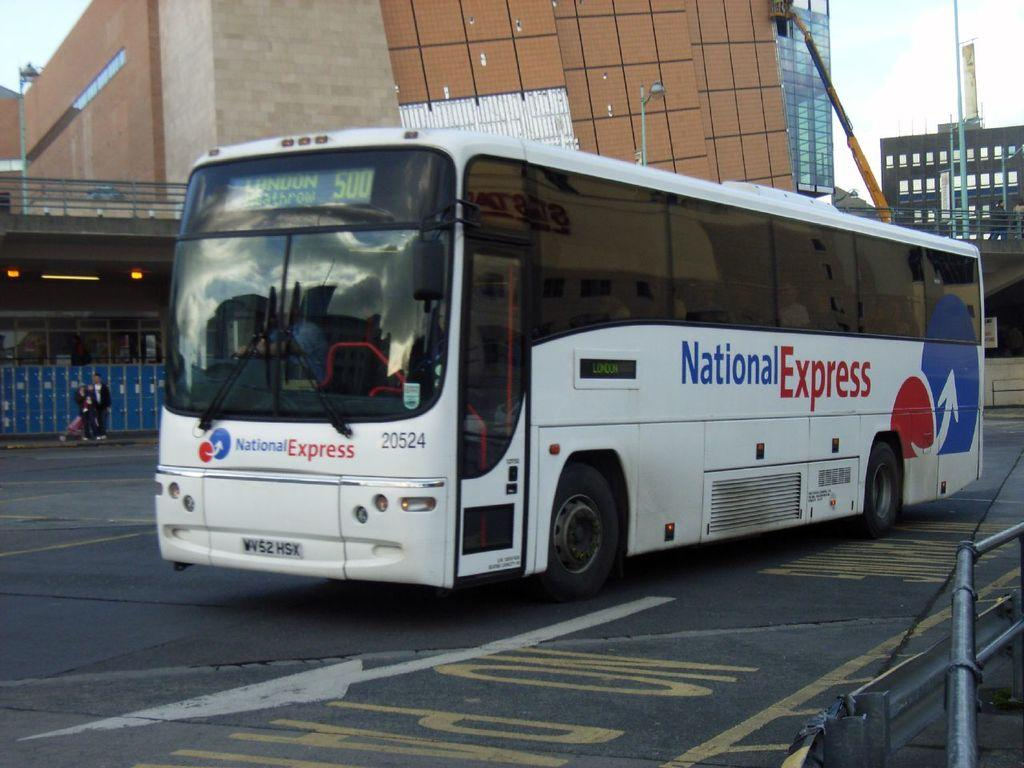<image>
Write a terse but informative summary of the picture. A red white and blue bus from national express. 